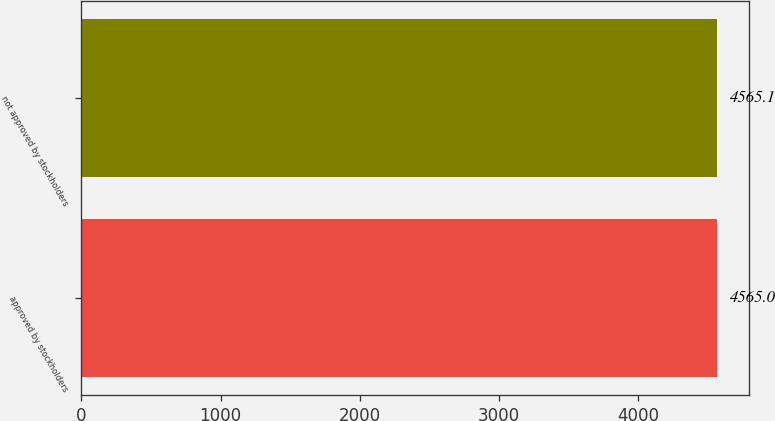Convert chart to OTSL. <chart><loc_0><loc_0><loc_500><loc_500><bar_chart><fcel>approved by stockholders<fcel>not approved by stockholders<nl><fcel>4565<fcel>4565.1<nl></chart> 